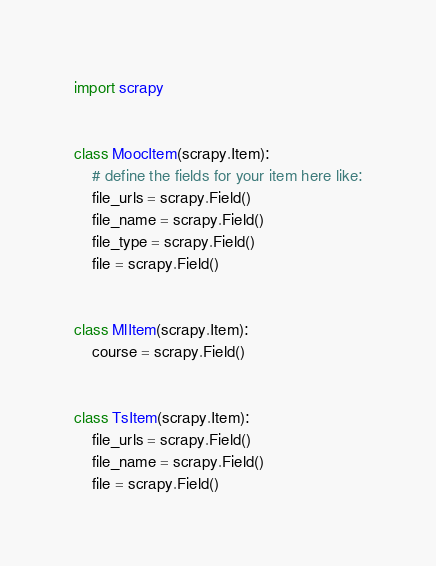Convert code to text. <code><loc_0><loc_0><loc_500><loc_500><_Python_>import scrapy


class MoocItem(scrapy.Item):
    # define the fields for your item here like:
    file_urls = scrapy.Field()
    file_name = scrapy.Field()
    file_type = scrapy.Field()
    file = scrapy.Field()


class MlItem(scrapy.Item):
    course = scrapy.Field()


class TsItem(scrapy.Item):
    file_urls = scrapy.Field()
    file_name = scrapy.Field()
    file = scrapy.Field()</code> 